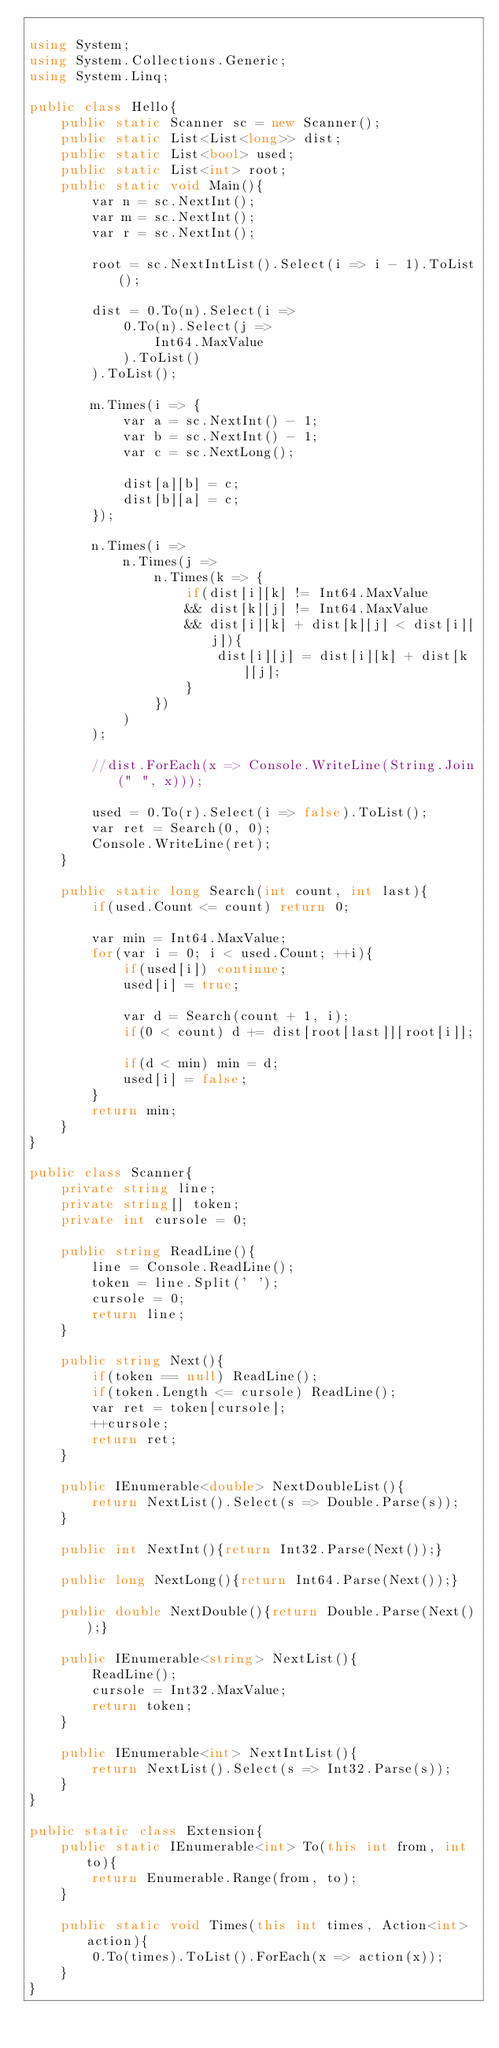Convert code to text. <code><loc_0><loc_0><loc_500><loc_500><_C#_>
using System;
using System.Collections.Generic;
using System.Linq;

public class Hello{
    public static Scanner sc = new Scanner();
    public static List<List<long>> dist;
    public static List<bool> used;
    public static List<int> root;
    public static void Main(){
        var n = sc.NextInt();
        var m = sc.NextInt();
        var r = sc.NextInt();
        
        root = sc.NextIntList().Select(i => i - 1).ToList();

        dist = 0.To(n).Select(i => 
            0.To(n).Select(j => 
                Int64.MaxValue
            ).ToList()
        ).ToList();
        
        m.Times(i => {
            var a = sc.NextInt() - 1;
            var b = sc.NextInt() - 1;
            var c = sc.NextLong();

            dist[a][b] = c;
            dist[b][a] = c;
        });
            
        n.Times(i =>
            n.Times(j =>
                n.Times(k => {
                    if(dist[i][k] != Int64.MaxValue
                    && dist[k][j] != Int64.MaxValue
                    && dist[i][k] + dist[k][j] < dist[i][j]){
                        dist[i][j] = dist[i][k] + dist[k][j];
                    }
                })
            )
        );
        
        //dist.ForEach(x => Console.WriteLine(String.Join(" ", x)));
        
        used = 0.To(r).Select(i => false).ToList();
        var ret = Search(0, 0);
        Console.WriteLine(ret);
    }
    
    public static long Search(int count, int last){
        if(used.Count <= count) return 0;

        var min = Int64.MaxValue;
        for(var i = 0; i < used.Count; ++i){
            if(used[i]) continue;
            used[i] = true;

            var d = Search(count + 1, i);
            if(0 < count) d += dist[root[last]][root[i]];

            if(d < min) min = d;
            used[i] = false;
        }
        return min;
    }
}

public class Scanner{
    private string line;
    private string[] token;
    private int cursole = 0;
    
    public string ReadLine(){
        line = Console.ReadLine();
        token = line.Split(' ');
        cursole = 0;
        return line;    
    }
    
    public string Next(){
        if(token == null) ReadLine();
        if(token.Length <= cursole) ReadLine();
        var ret = token[cursole];
        ++cursole;
        return ret;
    }

    public IEnumerable<double> NextDoubleList(){
        return NextList().Select(s => Double.Parse(s));
    }

    public int NextInt(){return Int32.Parse(Next());}
    
    public long NextLong(){return Int64.Parse(Next());}

    public double NextDouble(){return Double.Parse(Next());}

    public IEnumerable<string> NextList(){
        ReadLine();
        cursole = Int32.MaxValue;
        return token;
    }
    
    public IEnumerable<int> NextIntList(){
        return NextList().Select(s => Int32.Parse(s));
    }
}

public static class Extension{
    public static IEnumerable<int> To(this int from, int to){
        return Enumerable.Range(from, to);
    }

    public static void Times(this int times, Action<int> action){
        0.To(times).ToList().ForEach(x => action(x));
    }
}</code> 